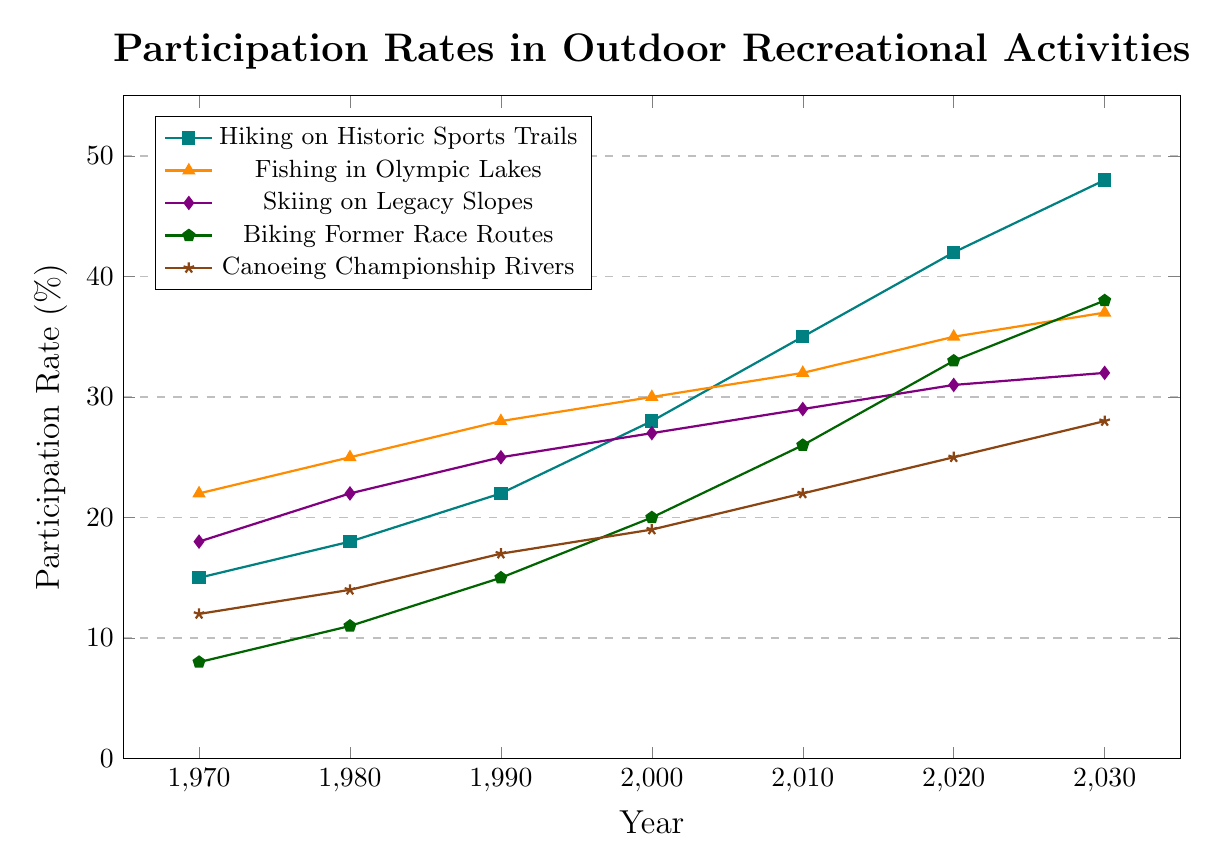What year did Hiking on Historic Sports Trails surpass a 30% participation rate? The line representing Hiking on Historic Sports Trails crosses the 30% mark between the years 2000 and 2010. Observing the data points, it surpasses 30% in 2010.
Answer: 2010 Compare the participation rates of Fishing in Olympic Lakes and Biking Former Race Routes in 2020. Which was higher and by how much? In 2020, the participation rate for Fishing in Olympic Lakes is 35%, whereas for Biking Former Race Routes it is 33%. The difference is 35% - 33% = 2%.
Answer: Fishing in Olympic Lakes by 2% Which activity showed the largest increase in participation from 1970 to 2030? Calculate the difference between the 1970 and 2030 participation rates for each activity and compare them: Hiking on Historic Sports Trails (48%-15%=33%), Fishing in Olympic Lakes (37%-22%=15%), Skiing on Legacy Slopes (32%-18%=14%), Biking Former Race Routes (38%-8%=30%), Canoeing Championship Rivers (28%-12%=16%). Hiking on Historic Sports Trails has the largest increase.
Answer: Hiking on Historic Sports Trails What was the average participation rate for Skiing on Legacy Slopes over the entire period? Add up all the participation rates for Skiing on Legacy Slopes and divide by the number of data points: (18+22+25+27+29+31+32)/7 = 26.29%.
Answer: 26.29% In which decade did Biking Former Race Routes see the greatest increase in participation? Compare the increases per decade: 1970-1980 (11-8=3%), 1980-1990 (15-11=4%), 1990-2000 (20-15=5%), 2000-2010 (26-20=6%), 2010-2020 (33-26=7%), 2020-2030 (38-33=5%). The decade with the greatest increase is 2010-2020.
Answer: 2010-2020 Between which two consecutive decades did Canoeing Championship Rivers see the smallest increase in participation? Compare the increases per decade: 1970-1980 (14-12=2%), 1980-1990 (17-14=3%), 1990-2000 (19-17=2%), 2000-2010 (22-19=3%), 2010-2020 (25-22=3%), 2020-2030 (28-25=3%). The smallest increase is tied between 1970-1980 and 1990-2000, both at 2%.
Answer: 1970-1980 and 1990-2000 